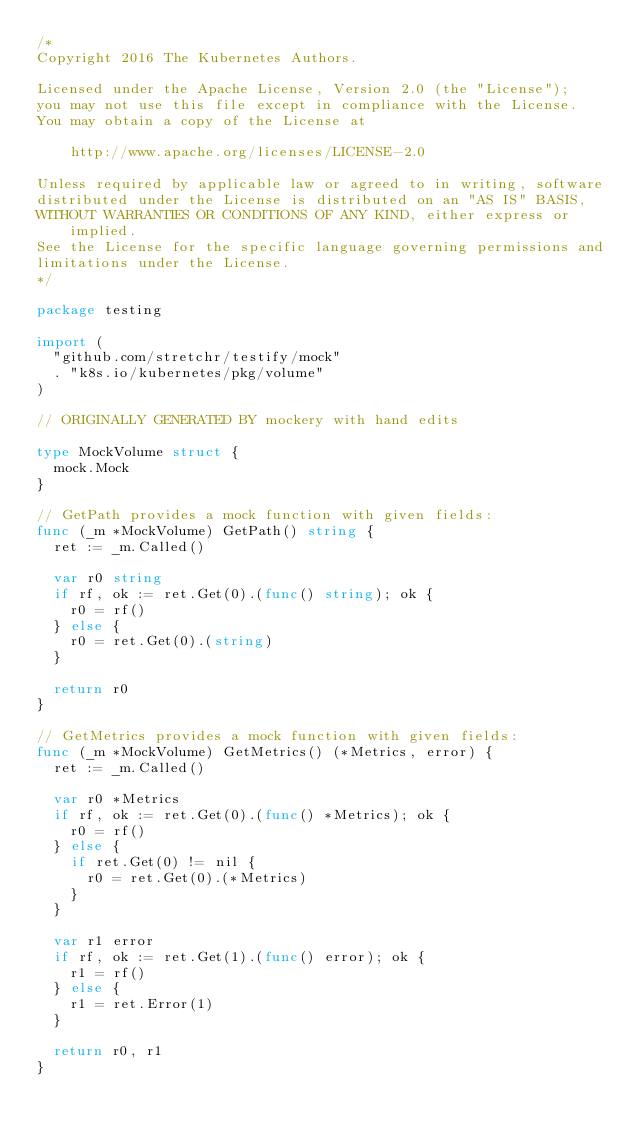Convert code to text. <code><loc_0><loc_0><loc_500><loc_500><_Go_>/*
Copyright 2016 The Kubernetes Authors.

Licensed under the Apache License, Version 2.0 (the "License");
you may not use this file except in compliance with the License.
You may obtain a copy of the License at

    http://www.apache.org/licenses/LICENSE-2.0

Unless required by applicable law or agreed to in writing, software
distributed under the License is distributed on an "AS IS" BASIS,
WITHOUT WARRANTIES OR CONDITIONS OF ANY KIND, either express or implied.
See the License for the specific language governing permissions and
limitations under the License.
*/

package testing

import (
	"github.com/stretchr/testify/mock"
	. "k8s.io/kubernetes/pkg/volume"
)

// ORIGINALLY GENERATED BY mockery with hand edits

type MockVolume struct {
	mock.Mock
}

// GetPath provides a mock function with given fields:
func (_m *MockVolume) GetPath() string {
	ret := _m.Called()

	var r0 string
	if rf, ok := ret.Get(0).(func() string); ok {
		r0 = rf()
	} else {
		r0 = ret.Get(0).(string)
	}

	return r0
}

// GetMetrics provides a mock function with given fields:
func (_m *MockVolume) GetMetrics() (*Metrics, error) {
	ret := _m.Called()

	var r0 *Metrics
	if rf, ok := ret.Get(0).(func() *Metrics); ok {
		r0 = rf()
	} else {
		if ret.Get(0) != nil {
			r0 = ret.Get(0).(*Metrics)
		}
	}

	var r1 error
	if rf, ok := ret.Get(1).(func() error); ok {
		r1 = rf()
	} else {
		r1 = ret.Error(1)
	}

	return r0, r1
}
</code> 